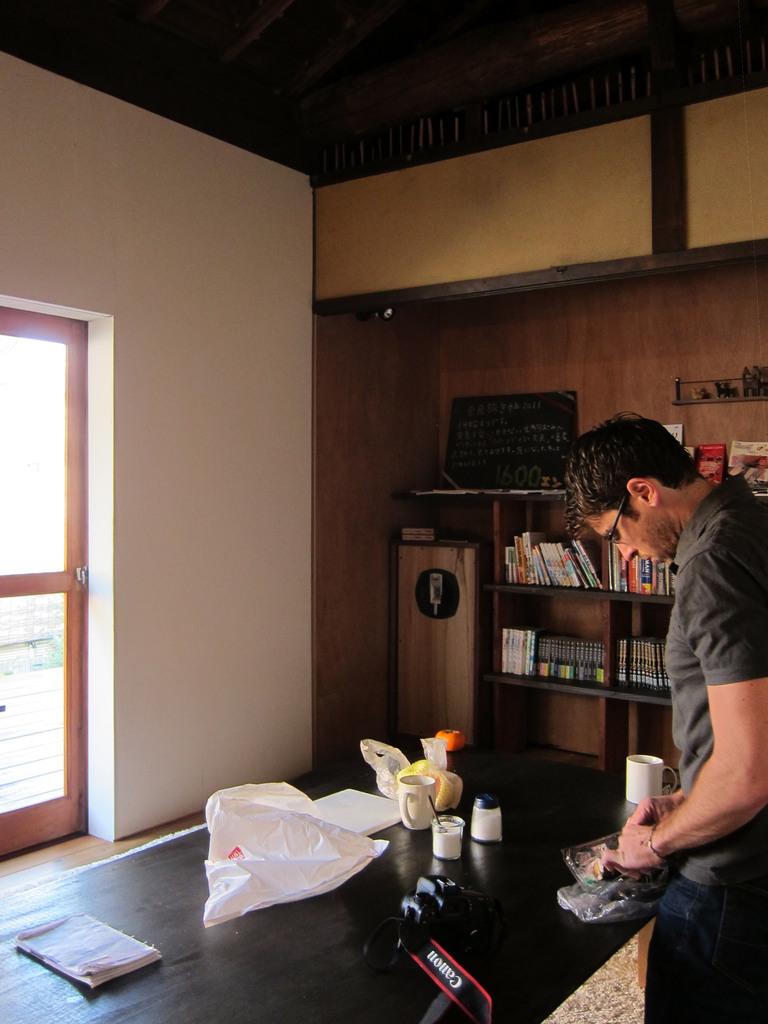What is the brand of camera here?
Your answer should be very brief. Canon. What does the chalk board relay?
Ensure brevity in your answer.  Unanswerable. 